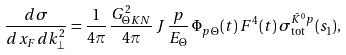Convert formula to latex. <formula><loc_0><loc_0><loc_500><loc_500>\frac { d \sigma } { d x _ { F } d k _ { \bot } ^ { 2 } } = \frac { 1 } { 4 \pi } \, \frac { G _ { \Theta K N } ^ { 2 } } { 4 \pi } \, J \, \frac { p } { E _ { \Theta } } \, \Phi _ { p \, \Theta } ( t ) \, F ^ { 4 } ( t ) \, \sigma _ { \text {tot} } ^ { \bar { K } ^ { 0 } p } ( s _ { 1 } ) ,</formula> 